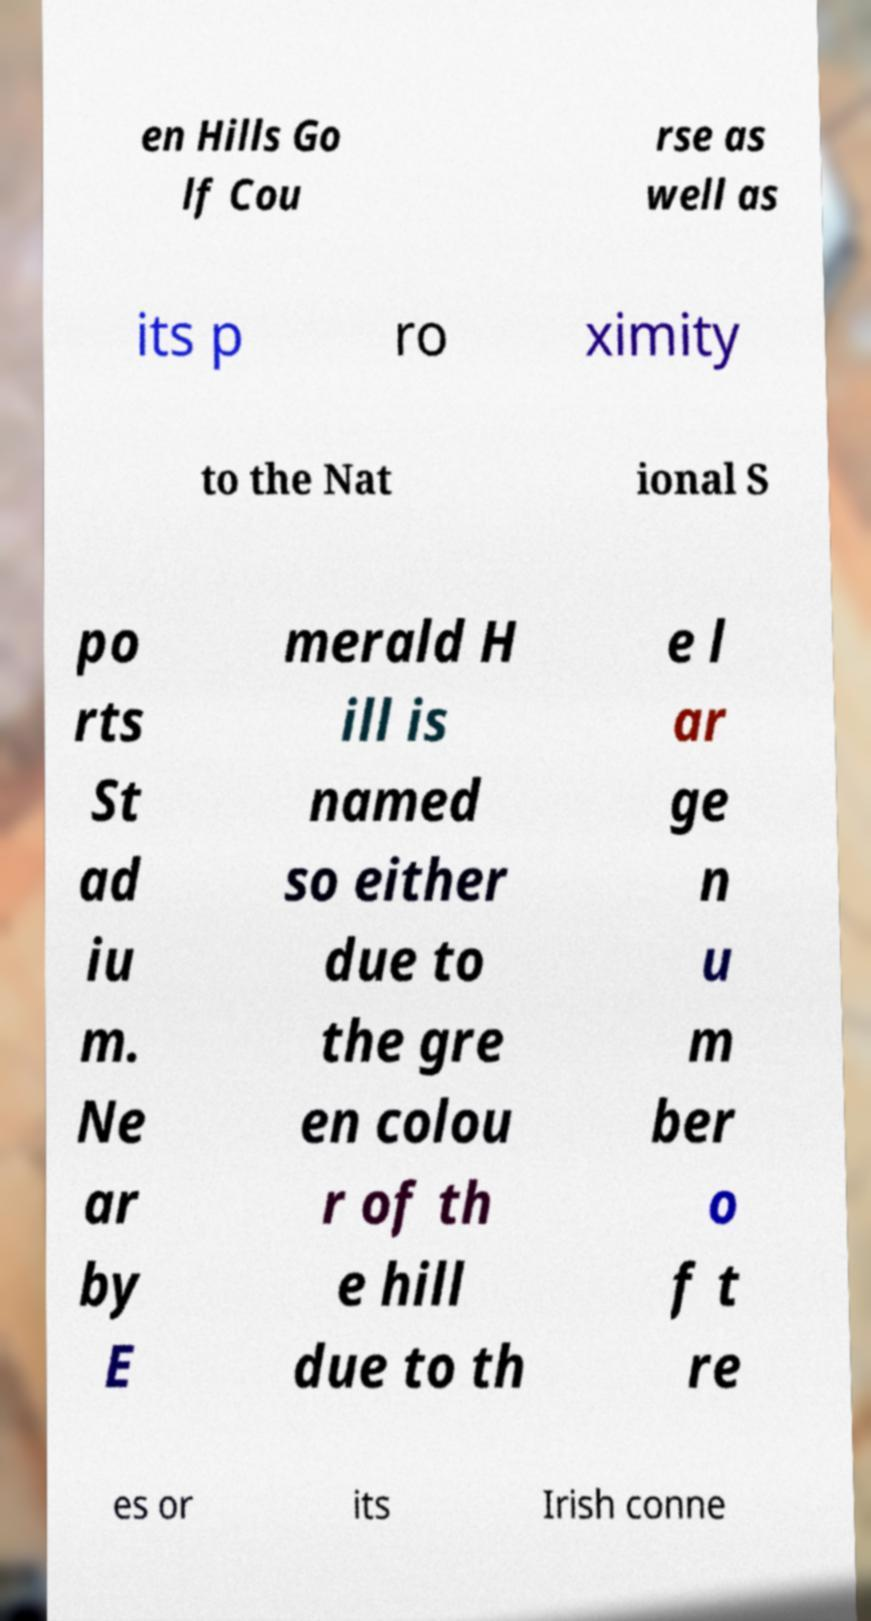Could you extract and type out the text from this image? en Hills Go lf Cou rse as well as its p ro ximity to the Nat ional S po rts St ad iu m. Ne ar by E merald H ill is named so either due to the gre en colou r of th e hill due to th e l ar ge n u m ber o f t re es or its Irish conne 